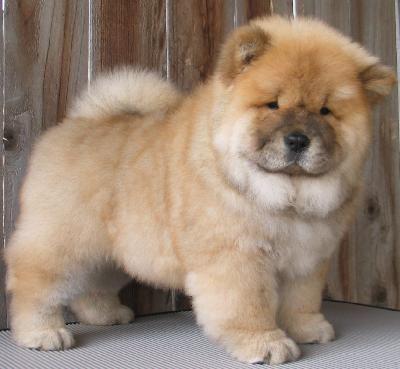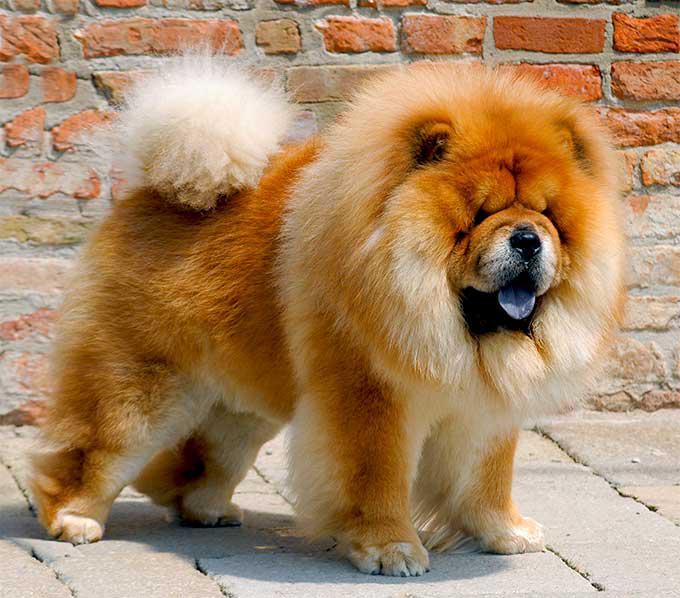The first image is the image on the left, the second image is the image on the right. Analyze the images presented: Is the assertion "There is exactly one dog in the right image." valid? Answer yes or no. Yes. The first image is the image on the left, the second image is the image on the right. Given the left and right images, does the statement "A chow dog with its blue tongue showing is standing on all fours with its body in profile." hold true? Answer yes or no. Yes. 